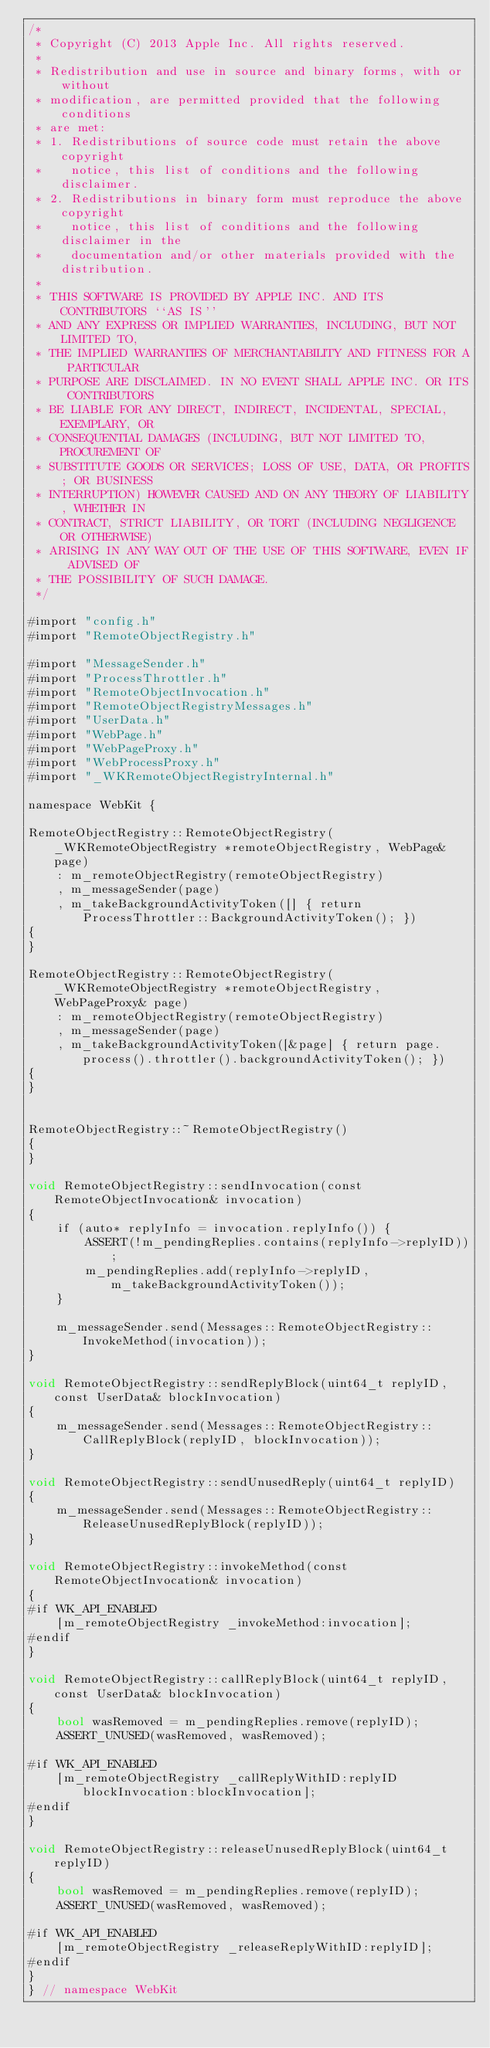Convert code to text. <code><loc_0><loc_0><loc_500><loc_500><_ObjectiveC_>/*
 * Copyright (C) 2013 Apple Inc. All rights reserved.
 *
 * Redistribution and use in source and binary forms, with or without
 * modification, are permitted provided that the following conditions
 * are met:
 * 1. Redistributions of source code must retain the above copyright
 *    notice, this list of conditions and the following disclaimer.
 * 2. Redistributions in binary form must reproduce the above copyright
 *    notice, this list of conditions and the following disclaimer in the
 *    documentation and/or other materials provided with the distribution.
 *
 * THIS SOFTWARE IS PROVIDED BY APPLE INC. AND ITS CONTRIBUTORS ``AS IS''
 * AND ANY EXPRESS OR IMPLIED WARRANTIES, INCLUDING, BUT NOT LIMITED TO,
 * THE IMPLIED WARRANTIES OF MERCHANTABILITY AND FITNESS FOR A PARTICULAR
 * PURPOSE ARE DISCLAIMED. IN NO EVENT SHALL APPLE INC. OR ITS CONTRIBUTORS
 * BE LIABLE FOR ANY DIRECT, INDIRECT, INCIDENTAL, SPECIAL, EXEMPLARY, OR
 * CONSEQUENTIAL DAMAGES (INCLUDING, BUT NOT LIMITED TO, PROCUREMENT OF
 * SUBSTITUTE GOODS OR SERVICES; LOSS OF USE, DATA, OR PROFITS; OR BUSINESS
 * INTERRUPTION) HOWEVER CAUSED AND ON ANY THEORY OF LIABILITY, WHETHER IN
 * CONTRACT, STRICT LIABILITY, OR TORT (INCLUDING NEGLIGENCE OR OTHERWISE)
 * ARISING IN ANY WAY OUT OF THE USE OF THIS SOFTWARE, EVEN IF ADVISED OF
 * THE POSSIBILITY OF SUCH DAMAGE.
 */

#import "config.h"
#import "RemoteObjectRegistry.h"

#import "MessageSender.h"
#import "ProcessThrottler.h"
#import "RemoteObjectInvocation.h"
#import "RemoteObjectRegistryMessages.h"
#import "UserData.h"
#import "WebPage.h"
#import "WebPageProxy.h"
#import "WebProcessProxy.h"
#import "_WKRemoteObjectRegistryInternal.h"

namespace WebKit {

RemoteObjectRegistry::RemoteObjectRegistry(_WKRemoteObjectRegistry *remoteObjectRegistry, WebPage& page)
    : m_remoteObjectRegistry(remoteObjectRegistry)
    , m_messageSender(page)
    , m_takeBackgroundActivityToken([] { return ProcessThrottler::BackgroundActivityToken(); })
{
}

RemoteObjectRegistry::RemoteObjectRegistry(_WKRemoteObjectRegistry *remoteObjectRegistry, WebPageProxy& page)
    : m_remoteObjectRegistry(remoteObjectRegistry)
    , m_messageSender(page)
    , m_takeBackgroundActivityToken([&page] { return page.process().throttler().backgroundActivityToken(); })
{
}


RemoteObjectRegistry::~RemoteObjectRegistry()
{
}

void RemoteObjectRegistry::sendInvocation(const RemoteObjectInvocation& invocation)
{
    if (auto* replyInfo = invocation.replyInfo()) {
        ASSERT(!m_pendingReplies.contains(replyInfo->replyID));
        m_pendingReplies.add(replyInfo->replyID, m_takeBackgroundActivityToken());
    }

    m_messageSender.send(Messages::RemoteObjectRegistry::InvokeMethod(invocation));
}

void RemoteObjectRegistry::sendReplyBlock(uint64_t replyID, const UserData& blockInvocation)
{
    m_messageSender.send(Messages::RemoteObjectRegistry::CallReplyBlock(replyID, blockInvocation));
}

void RemoteObjectRegistry::sendUnusedReply(uint64_t replyID)
{
    m_messageSender.send(Messages::RemoteObjectRegistry::ReleaseUnusedReplyBlock(replyID));
}

void RemoteObjectRegistry::invokeMethod(const RemoteObjectInvocation& invocation)
{
#if WK_API_ENABLED
    [m_remoteObjectRegistry _invokeMethod:invocation];
#endif
}

void RemoteObjectRegistry::callReplyBlock(uint64_t replyID, const UserData& blockInvocation)
{
    bool wasRemoved = m_pendingReplies.remove(replyID);
    ASSERT_UNUSED(wasRemoved, wasRemoved);

#if WK_API_ENABLED
    [m_remoteObjectRegistry _callReplyWithID:replyID blockInvocation:blockInvocation];
#endif
}

void RemoteObjectRegistry::releaseUnusedReplyBlock(uint64_t replyID)
{
    bool wasRemoved = m_pendingReplies.remove(replyID);
    ASSERT_UNUSED(wasRemoved, wasRemoved);

#if WK_API_ENABLED
    [m_remoteObjectRegistry _releaseReplyWithID:replyID];
#endif
}
} // namespace WebKit
</code> 